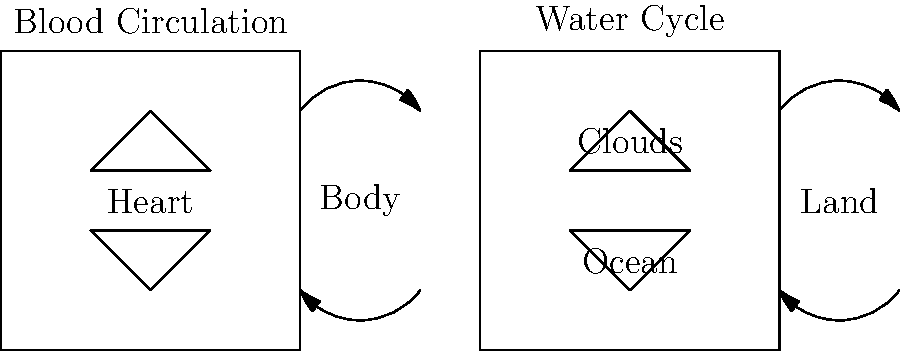Analyze the similarities between blood circulation in living organisms and the geological water cycle as depicted in the side-by-side diagrams. Identify the key common process that drives both systems and explain how it contributes to the continuous movement of fluids in each cycle. To answer this question, let's analyze the similarities between blood circulation and the water cycle step-by-step:

1. Closed loop systems: Both diagrams show closed loop systems where fluids (blood and water) circulate continuously.

2. Central pumping mechanism:
   - In blood circulation: The heart acts as the central pump.
   - In the water cycle: The sun's energy acts as the driving force, causing evaporation.

3. Movement between two main areas:
   - Blood circulation: Between the heart and body
   - Water cycle: Between the ocean/water bodies and land/atmosphere

4. Continuous flow:
   - Blood: Flows from the heart to the body and back
   - Water: Moves from oceans to clouds to land and back to oceans

5. Phase changes:
   - Blood: No significant phase changes
   - Water: Changes from liquid to gas (evaporation) and back to liquid (condensation)

6. Key common process: The primary similarity driving both systems is the concept of pressure differentials.

   - In blood circulation:
     a. The heart creates high pressure by contracting (systole)
     b. This pushes blood through arteries to areas of lower pressure
     c. Blood returns to the heart through veins due to pressure gradients

   - In the water cycle:
     a. The sun heats water, creating areas of high vapor pressure
     b. Water vapor moves to areas of lower pressure in the atmosphere
     c. Condensation and precipitation occur as vapor moves to lower pressure areas

7. Continuous movement:
   - The pressure differentials in both systems ensure that fluids keep moving
   - This continuous movement is essential for distributing nutrients, oxygen, and water in their respective systems

The key common process that drives both systems is the creation and maintenance of pressure differentials, which results in the continuous movement of fluids from areas of high pressure to areas of low pressure.
Answer: Pressure differentials drive continuous fluid movement in both cycles. 